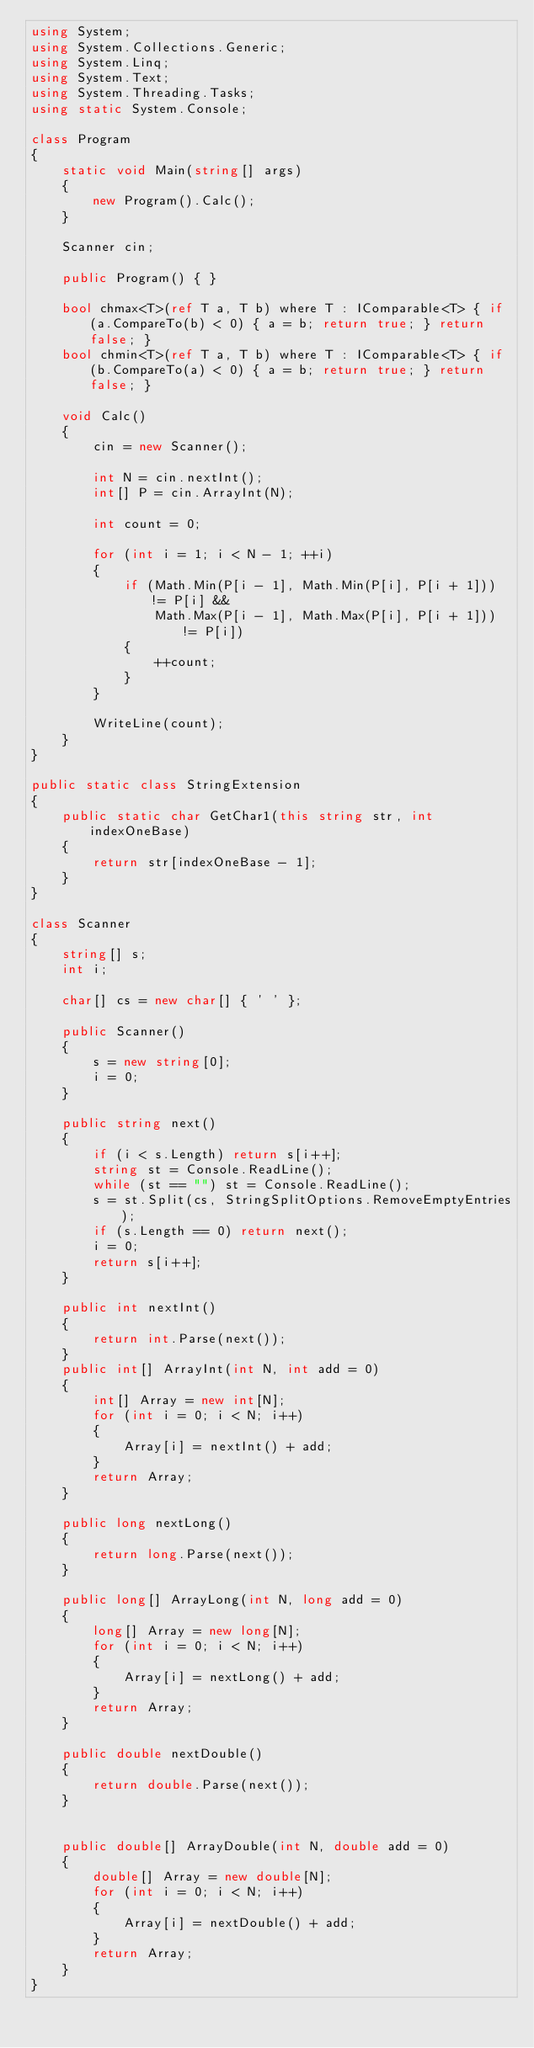<code> <loc_0><loc_0><loc_500><loc_500><_C#_>using System;
using System.Collections.Generic;
using System.Linq;
using System.Text;
using System.Threading.Tasks;
using static System.Console;

class Program
{
    static void Main(string[] args)
    {
        new Program().Calc();
    }

    Scanner cin;

    public Program() { }

    bool chmax<T>(ref T a, T b) where T : IComparable<T> { if (a.CompareTo(b) < 0) { a = b; return true; } return false; }
    bool chmin<T>(ref T a, T b) where T : IComparable<T> { if (b.CompareTo(a) < 0) { a = b; return true; } return false; }

    void Calc()
    {
        cin = new Scanner();

        int N = cin.nextInt();
        int[] P = cin.ArrayInt(N);

        int count = 0;

        for (int i = 1; i < N - 1; ++i)
        {
            if (Math.Min(P[i - 1], Math.Min(P[i], P[i + 1])) != P[i] &&
                Math.Max(P[i - 1], Math.Max(P[i], P[i + 1])) != P[i])
            {
                ++count;
            }
        }

        WriteLine(count);
    }
}

public static class StringExtension
{
    public static char GetChar1(this string str, int indexOneBase)
    {
        return str[indexOneBase - 1];
    }
}

class Scanner
{
    string[] s;
    int i;

    char[] cs = new char[] { ' ' };

    public Scanner()
    {
        s = new string[0];
        i = 0;
    }

    public string next()
    {
        if (i < s.Length) return s[i++];
        string st = Console.ReadLine();
        while (st == "") st = Console.ReadLine();
        s = st.Split(cs, StringSplitOptions.RemoveEmptyEntries);
        if (s.Length == 0) return next();
        i = 0;
        return s[i++];
    }

    public int nextInt()
    {
        return int.Parse(next());
    }
    public int[] ArrayInt(int N, int add = 0)
    {
        int[] Array = new int[N];
        for (int i = 0; i < N; i++)
        {
            Array[i] = nextInt() + add;
        }
        return Array;
    }

    public long nextLong()
    {
        return long.Parse(next());
    }

    public long[] ArrayLong(int N, long add = 0)
    {
        long[] Array = new long[N];
        for (int i = 0; i < N; i++)
        {
            Array[i] = nextLong() + add;
        }
        return Array;
    }

    public double nextDouble()
    {
        return double.Parse(next());
    }


    public double[] ArrayDouble(int N, double add = 0)
    {
        double[] Array = new double[N];
        for (int i = 0; i < N; i++)
        {
            Array[i] = nextDouble() + add;
        }
        return Array;
    }
}
</code> 